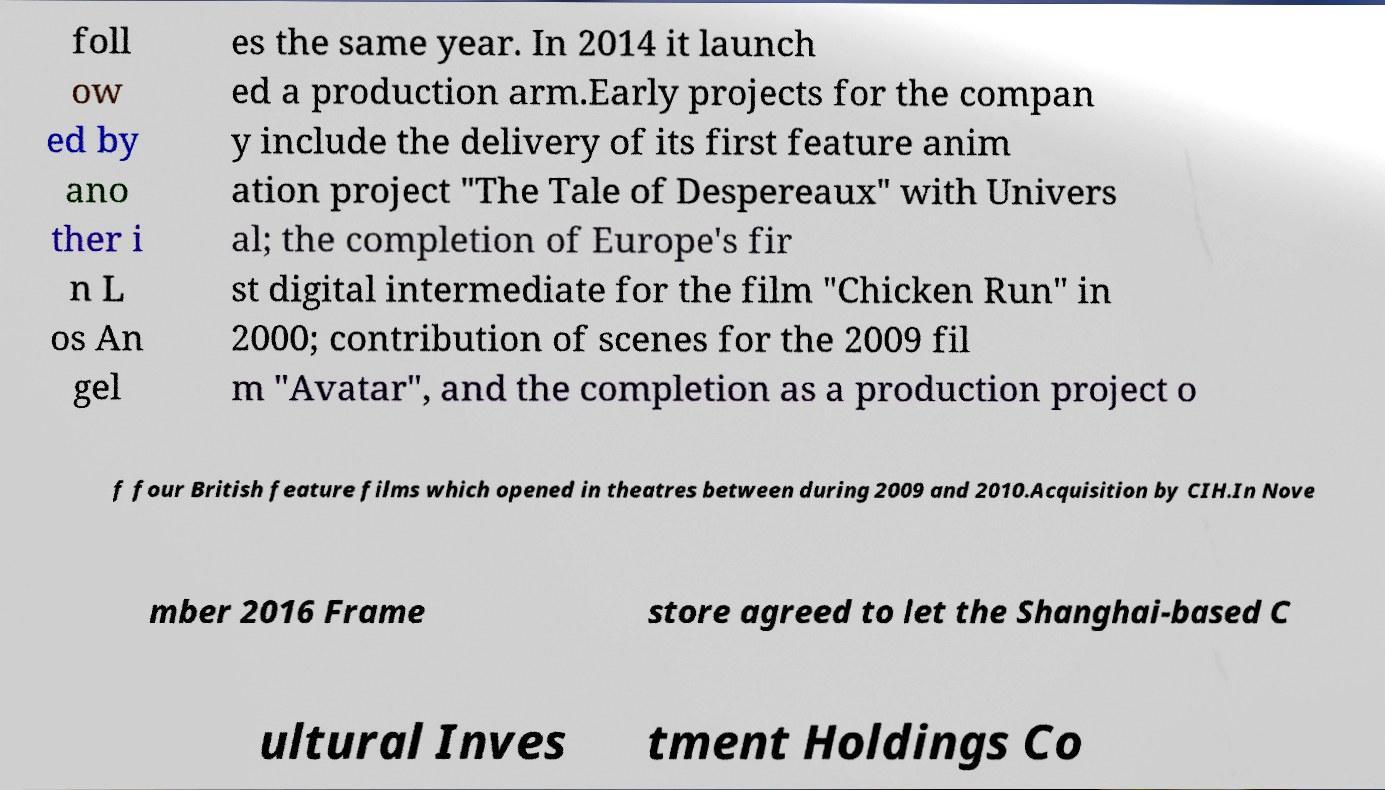Can you read and provide the text displayed in the image?This photo seems to have some interesting text. Can you extract and type it out for me? foll ow ed by ano ther i n L os An gel es the same year. In 2014 it launch ed a production arm.Early projects for the compan y include the delivery of its first feature anim ation project "The Tale of Despereaux" with Univers al; the completion of Europe's fir st digital intermediate for the film "Chicken Run" in 2000; contribution of scenes for the 2009 fil m "Avatar", and the completion as a production project o f four British feature films which opened in theatres between during 2009 and 2010.Acquisition by CIH.In Nove mber 2016 Frame store agreed to let the Shanghai-based C ultural Inves tment Holdings Co 